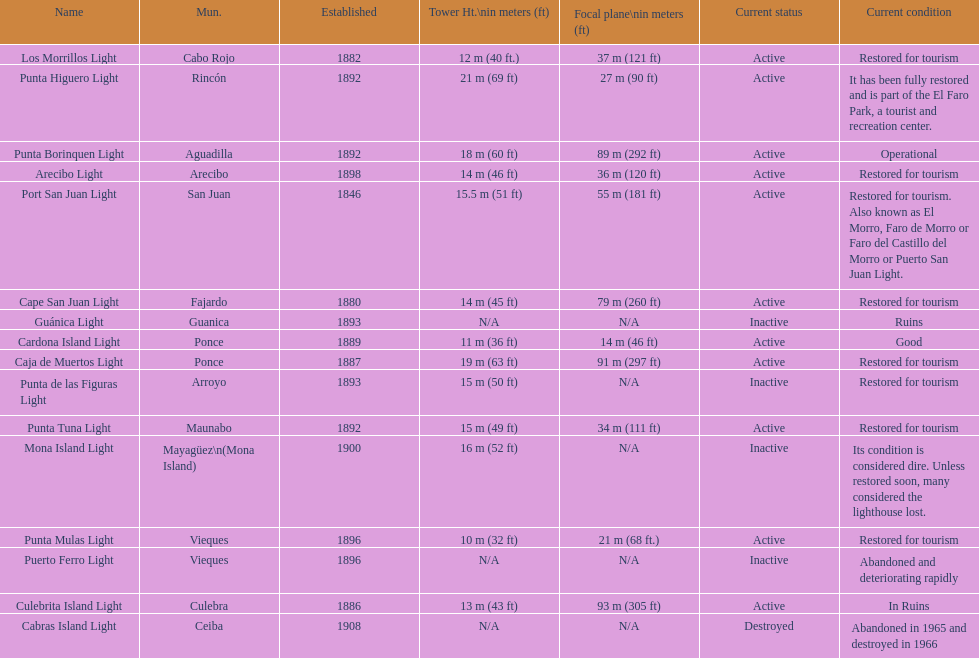Were any towers established before the year 1800? No. 